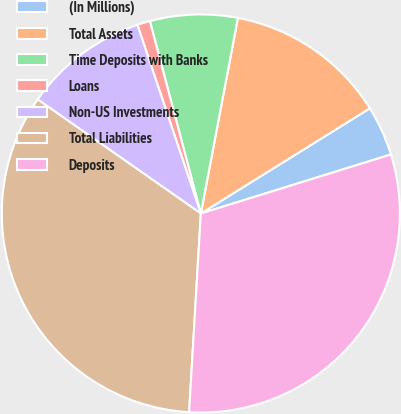Convert chart to OTSL. <chart><loc_0><loc_0><loc_500><loc_500><pie_chart><fcel>(In Millions)<fcel>Total Assets<fcel>Time Deposits with Banks<fcel>Loans<fcel>Non-US Investments<fcel>Total Liabilities<fcel>Deposits<nl><fcel>4.07%<fcel>13.16%<fcel>7.1%<fcel>1.04%<fcel>10.13%<fcel>33.77%<fcel>30.73%<nl></chart> 